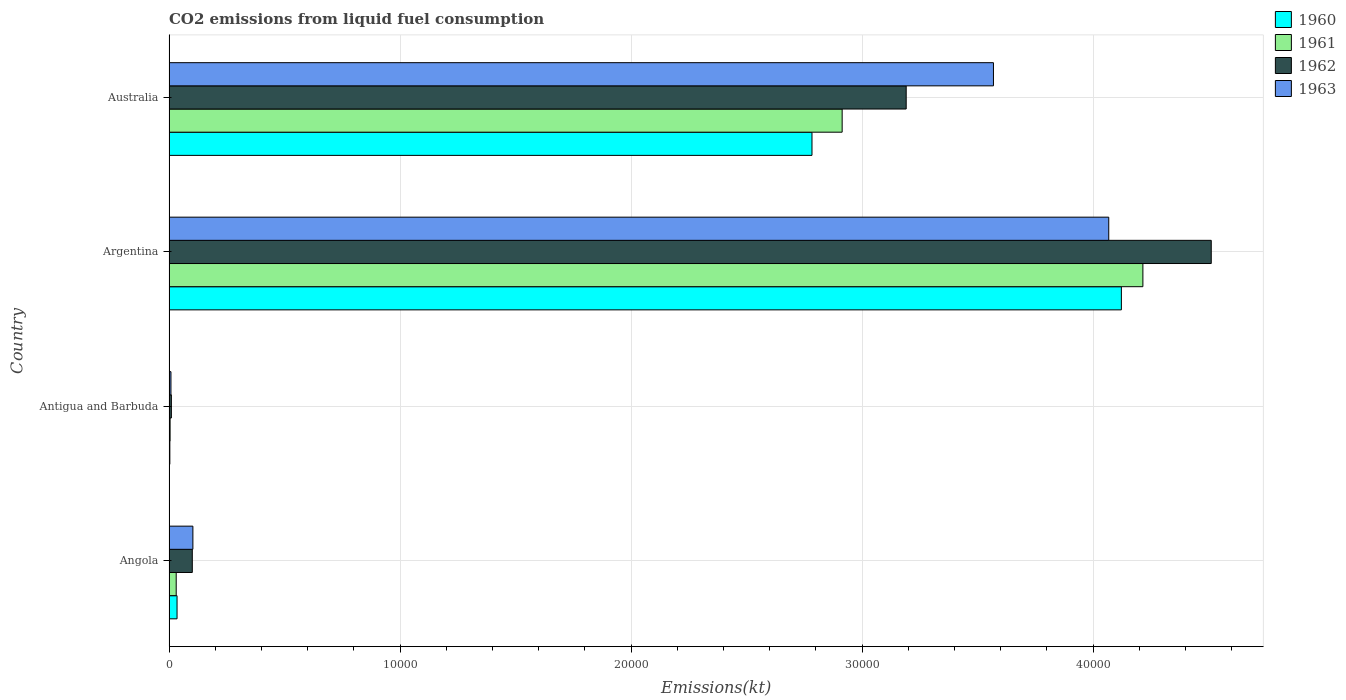Are the number of bars on each tick of the Y-axis equal?
Give a very brief answer. Yes. In how many cases, is the number of bars for a given country not equal to the number of legend labels?
Your response must be concise. 0. What is the amount of CO2 emitted in 1961 in Angola?
Keep it short and to the point. 311.69. Across all countries, what is the maximum amount of CO2 emitted in 1962?
Ensure brevity in your answer.  4.51e+04. Across all countries, what is the minimum amount of CO2 emitted in 1962?
Keep it short and to the point. 102.68. In which country was the amount of CO2 emitted in 1961 minimum?
Offer a very short reply. Antigua and Barbuda. What is the total amount of CO2 emitted in 1961 in the graph?
Offer a terse response. 7.17e+04. What is the difference between the amount of CO2 emitted in 1963 in Angola and that in Argentina?
Ensure brevity in your answer.  -3.96e+04. What is the difference between the amount of CO2 emitted in 1960 in Argentina and the amount of CO2 emitted in 1961 in Antigua and Barbuda?
Ensure brevity in your answer.  4.12e+04. What is the average amount of CO2 emitted in 1960 per country?
Offer a very short reply. 1.74e+04. What is the difference between the amount of CO2 emitted in 1961 and amount of CO2 emitted in 1963 in Argentina?
Offer a very short reply. 1477.8. In how many countries, is the amount of CO2 emitted in 1960 greater than 24000 kt?
Provide a short and direct response. 2. What is the ratio of the amount of CO2 emitted in 1963 in Angola to that in Antigua and Barbuda?
Keep it short and to the point. 12.26. What is the difference between the highest and the second highest amount of CO2 emitted in 1960?
Ensure brevity in your answer.  1.34e+04. What is the difference between the highest and the lowest amount of CO2 emitted in 1961?
Offer a terse response. 4.21e+04. Is it the case that in every country, the sum of the amount of CO2 emitted in 1961 and amount of CO2 emitted in 1960 is greater than the sum of amount of CO2 emitted in 1963 and amount of CO2 emitted in 1962?
Offer a terse response. No. What does the 1st bar from the top in Argentina represents?
Your answer should be very brief. 1963. Is it the case that in every country, the sum of the amount of CO2 emitted in 1963 and amount of CO2 emitted in 1962 is greater than the amount of CO2 emitted in 1960?
Your answer should be compact. Yes. How many bars are there?
Keep it short and to the point. 16. Are all the bars in the graph horizontal?
Offer a terse response. Yes. What is the difference between two consecutive major ticks on the X-axis?
Provide a succinct answer. 10000. Are the values on the major ticks of X-axis written in scientific E-notation?
Give a very brief answer. No. Does the graph contain any zero values?
Give a very brief answer. No. Does the graph contain grids?
Your answer should be very brief. Yes. Where does the legend appear in the graph?
Offer a terse response. Top right. How many legend labels are there?
Your answer should be compact. 4. What is the title of the graph?
Your answer should be very brief. CO2 emissions from liquid fuel consumption. What is the label or title of the X-axis?
Your answer should be compact. Emissions(kt). What is the label or title of the Y-axis?
Your answer should be very brief. Country. What is the Emissions(kt) in 1960 in Angola?
Your answer should be compact. 348.37. What is the Emissions(kt) in 1961 in Angola?
Your answer should be compact. 311.69. What is the Emissions(kt) in 1962 in Angola?
Provide a succinct answer. 1008.42. What is the Emissions(kt) of 1963 in Angola?
Give a very brief answer. 1034.09. What is the Emissions(kt) of 1960 in Antigua and Barbuda?
Keep it short and to the point. 36.67. What is the Emissions(kt) of 1961 in Antigua and Barbuda?
Your answer should be very brief. 47.67. What is the Emissions(kt) of 1962 in Antigua and Barbuda?
Your answer should be very brief. 102.68. What is the Emissions(kt) in 1963 in Antigua and Barbuda?
Make the answer very short. 84.34. What is the Emissions(kt) in 1960 in Argentina?
Provide a short and direct response. 4.12e+04. What is the Emissions(kt) in 1961 in Argentina?
Provide a succinct answer. 4.22e+04. What is the Emissions(kt) in 1962 in Argentina?
Offer a very short reply. 4.51e+04. What is the Emissions(kt) of 1963 in Argentina?
Offer a very short reply. 4.07e+04. What is the Emissions(kt) in 1960 in Australia?
Offer a very short reply. 2.78e+04. What is the Emissions(kt) in 1961 in Australia?
Your answer should be very brief. 2.91e+04. What is the Emissions(kt) of 1962 in Australia?
Your answer should be very brief. 3.19e+04. What is the Emissions(kt) of 1963 in Australia?
Keep it short and to the point. 3.57e+04. Across all countries, what is the maximum Emissions(kt) of 1960?
Give a very brief answer. 4.12e+04. Across all countries, what is the maximum Emissions(kt) of 1961?
Your answer should be very brief. 4.22e+04. Across all countries, what is the maximum Emissions(kt) of 1962?
Offer a very short reply. 4.51e+04. Across all countries, what is the maximum Emissions(kt) of 1963?
Offer a terse response. 4.07e+04. Across all countries, what is the minimum Emissions(kt) in 1960?
Your answer should be compact. 36.67. Across all countries, what is the minimum Emissions(kt) in 1961?
Ensure brevity in your answer.  47.67. Across all countries, what is the minimum Emissions(kt) of 1962?
Offer a very short reply. 102.68. Across all countries, what is the minimum Emissions(kt) in 1963?
Ensure brevity in your answer.  84.34. What is the total Emissions(kt) of 1960 in the graph?
Make the answer very short. 6.94e+04. What is the total Emissions(kt) in 1961 in the graph?
Provide a succinct answer. 7.17e+04. What is the total Emissions(kt) in 1962 in the graph?
Your answer should be compact. 7.81e+04. What is the total Emissions(kt) in 1963 in the graph?
Your response must be concise. 7.75e+04. What is the difference between the Emissions(kt) of 1960 in Angola and that in Antigua and Barbuda?
Keep it short and to the point. 311.69. What is the difference between the Emissions(kt) in 1961 in Angola and that in Antigua and Barbuda?
Your response must be concise. 264.02. What is the difference between the Emissions(kt) in 1962 in Angola and that in Antigua and Barbuda?
Give a very brief answer. 905.75. What is the difference between the Emissions(kt) of 1963 in Angola and that in Antigua and Barbuda?
Offer a terse response. 949.75. What is the difference between the Emissions(kt) of 1960 in Angola and that in Argentina?
Offer a terse response. -4.09e+04. What is the difference between the Emissions(kt) in 1961 in Angola and that in Argentina?
Offer a terse response. -4.18e+04. What is the difference between the Emissions(kt) in 1962 in Angola and that in Argentina?
Give a very brief answer. -4.41e+04. What is the difference between the Emissions(kt) in 1963 in Angola and that in Argentina?
Offer a very short reply. -3.96e+04. What is the difference between the Emissions(kt) in 1960 in Angola and that in Australia?
Provide a short and direct response. -2.75e+04. What is the difference between the Emissions(kt) of 1961 in Angola and that in Australia?
Provide a short and direct response. -2.88e+04. What is the difference between the Emissions(kt) in 1962 in Angola and that in Australia?
Ensure brevity in your answer.  -3.09e+04. What is the difference between the Emissions(kt) of 1963 in Angola and that in Australia?
Your answer should be very brief. -3.47e+04. What is the difference between the Emissions(kt) in 1960 in Antigua and Barbuda and that in Argentina?
Give a very brief answer. -4.12e+04. What is the difference between the Emissions(kt) of 1961 in Antigua and Barbuda and that in Argentina?
Your answer should be compact. -4.21e+04. What is the difference between the Emissions(kt) of 1962 in Antigua and Barbuda and that in Argentina?
Offer a terse response. -4.50e+04. What is the difference between the Emissions(kt) of 1963 in Antigua and Barbuda and that in Argentina?
Make the answer very short. -4.06e+04. What is the difference between the Emissions(kt) of 1960 in Antigua and Barbuda and that in Australia?
Keep it short and to the point. -2.78e+04. What is the difference between the Emissions(kt) in 1961 in Antigua and Barbuda and that in Australia?
Keep it short and to the point. -2.91e+04. What is the difference between the Emissions(kt) of 1962 in Antigua and Barbuda and that in Australia?
Make the answer very short. -3.18e+04. What is the difference between the Emissions(kt) of 1963 in Antigua and Barbuda and that in Australia?
Make the answer very short. -3.56e+04. What is the difference between the Emissions(kt) of 1960 in Argentina and that in Australia?
Provide a succinct answer. 1.34e+04. What is the difference between the Emissions(kt) of 1961 in Argentina and that in Australia?
Provide a succinct answer. 1.30e+04. What is the difference between the Emissions(kt) in 1962 in Argentina and that in Australia?
Make the answer very short. 1.32e+04. What is the difference between the Emissions(kt) of 1963 in Argentina and that in Australia?
Ensure brevity in your answer.  4990.79. What is the difference between the Emissions(kt) of 1960 in Angola and the Emissions(kt) of 1961 in Antigua and Barbuda?
Ensure brevity in your answer.  300.69. What is the difference between the Emissions(kt) of 1960 in Angola and the Emissions(kt) of 1962 in Antigua and Barbuda?
Provide a short and direct response. 245.69. What is the difference between the Emissions(kt) of 1960 in Angola and the Emissions(kt) of 1963 in Antigua and Barbuda?
Your response must be concise. 264.02. What is the difference between the Emissions(kt) in 1961 in Angola and the Emissions(kt) in 1962 in Antigua and Barbuda?
Your answer should be very brief. 209.02. What is the difference between the Emissions(kt) of 1961 in Angola and the Emissions(kt) of 1963 in Antigua and Barbuda?
Offer a very short reply. 227.35. What is the difference between the Emissions(kt) in 1962 in Angola and the Emissions(kt) in 1963 in Antigua and Barbuda?
Offer a very short reply. 924.08. What is the difference between the Emissions(kt) of 1960 in Angola and the Emissions(kt) of 1961 in Argentina?
Provide a succinct answer. -4.18e+04. What is the difference between the Emissions(kt) of 1960 in Angola and the Emissions(kt) of 1962 in Argentina?
Your answer should be compact. -4.48e+04. What is the difference between the Emissions(kt) in 1960 in Angola and the Emissions(kt) in 1963 in Argentina?
Offer a very short reply. -4.03e+04. What is the difference between the Emissions(kt) of 1961 in Angola and the Emissions(kt) of 1962 in Argentina?
Make the answer very short. -4.48e+04. What is the difference between the Emissions(kt) in 1961 in Angola and the Emissions(kt) in 1963 in Argentina?
Your answer should be very brief. -4.04e+04. What is the difference between the Emissions(kt) in 1962 in Angola and the Emissions(kt) in 1963 in Argentina?
Your response must be concise. -3.97e+04. What is the difference between the Emissions(kt) of 1960 in Angola and the Emissions(kt) of 1961 in Australia?
Keep it short and to the point. -2.88e+04. What is the difference between the Emissions(kt) of 1960 in Angola and the Emissions(kt) of 1962 in Australia?
Your answer should be very brief. -3.16e+04. What is the difference between the Emissions(kt) in 1960 in Angola and the Emissions(kt) in 1963 in Australia?
Keep it short and to the point. -3.53e+04. What is the difference between the Emissions(kt) in 1961 in Angola and the Emissions(kt) in 1962 in Australia?
Ensure brevity in your answer.  -3.16e+04. What is the difference between the Emissions(kt) of 1961 in Angola and the Emissions(kt) of 1963 in Australia?
Offer a very short reply. -3.54e+04. What is the difference between the Emissions(kt) of 1962 in Angola and the Emissions(kt) of 1963 in Australia?
Make the answer very short. -3.47e+04. What is the difference between the Emissions(kt) of 1960 in Antigua and Barbuda and the Emissions(kt) of 1961 in Argentina?
Provide a succinct answer. -4.21e+04. What is the difference between the Emissions(kt) of 1960 in Antigua and Barbuda and the Emissions(kt) of 1962 in Argentina?
Ensure brevity in your answer.  -4.51e+04. What is the difference between the Emissions(kt) of 1960 in Antigua and Barbuda and the Emissions(kt) of 1963 in Argentina?
Keep it short and to the point. -4.06e+04. What is the difference between the Emissions(kt) of 1961 in Antigua and Barbuda and the Emissions(kt) of 1962 in Argentina?
Ensure brevity in your answer.  -4.51e+04. What is the difference between the Emissions(kt) in 1961 in Antigua and Barbuda and the Emissions(kt) in 1963 in Argentina?
Offer a very short reply. -4.06e+04. What is the difference between the Emissions(kt) of 1962 in Antigua and Barbuda and the Emissions(kt) of 1963 in Argentina?
Offer a very short reply. -4.06e+04. What is the difference between the Emissions(kt) in 1960 in Antigua and Barbuda and the Emissions(kt) in 1961 in Australia?
Give a very brief answer. -2.91e+04. What is the difference between the Emissions(kt) in 1960 in Antigua and Barbuda and the Emissions(kt) in 1962 in Australia?
Ensure brevity in your answer.  -3.19e+04. What is the difference between the Emissions(kt) in 1960 in Antigua and Barbuda and the Emissions(kt) in 1963 in Australia?
Your answer should be compact. -3.57e+04. What is the difference between the Emissions(kt) in 1961 in Antigua and Barbuda and the Emissions(kt) in 1962 in Australia?
Your answer should be compact. -3.19e+04. What is the difference between the Emissions(kt) of 1961 in Antigua and Barbuda and the Emissions(kt) of 1963 in Australia?
Offer a very short reply. -3.56e+04. What is the difference between the Emissions(kt) in 1962 in Antigua and Barbuda and the Emissions(kt) in 1963 in Australia?
Keep it short and to the point. -3.56e+04. What is the difference between the Emissions(kt) of 1960 in Argentina and the Emissions(kt) of 1961 in Australia?
Your response must be concise. 1.21e+04. What is the difference between the Emissions(kt) of 1960 in Argentina and the Emissions(kt) of 1962 in Australia?
Give a very brief answer. 9314.18. What is the difference between the Emissions(kt) of 1960 in Argentina and the Emissions(kt) of 1963 in Australia?
Your response must be concise. 5537.17. What is the difference between the Emissions(kt) of 1961 in Argentina and the Emissions(kt) of 1962 in Australia?
Your answer should be very brief. 1.02e+04. What is the difference between the Emissions(kt) of 1961 in Argentina and the Emissions(kt) of 1963 in Australia?
Your answer should be very brief. 6468.59. What is the difference between the Emissions(kt) in 1962 in Argentina and the Emissions(kt) in 1963 in Australia?
Your response must be concise. 9427.86. What is the average Emissions(kt) in 1960 per country?
Offer a terse response. 1.74e+04. What is the average Emissions(kt) in 1961 per country?
Provide a succinct answer. 1.79e+04. What is the average Emissions(kt) in 1962 per country?
Keep it short and to the point. 1.95e+04. What is the average Emissions(kt) in 1963 per country?
Provide a succinct answer. 1.94e+04. What is the difference between the Emissions(kt) of 1960 and Emissions(kt) of 1961 in Angola?
Your answer should be very brief. 36.67. What is the difference between the Emissions(kt) in 1960 and Emissions(kt) in 1962 in Angola?
Keep it short and to the point. -660.06. What is the difference between the Emissions(kt) of 1960 and Emissions(kt) of 1963 in Angola?
Make the answer very short. -685.73. What is the difference between the Emissions(kt) of 1961 and Emissions(kt) of 1962 in Angola?
Provide a short and direct response. -696.73. What is the difference between the Emissions(kt) of 1961 and Emissions(kt) of 1963 in Angola?
Give a very brief answer. -722.4. What is the difference between the Emissions(kt) of 1962 and Emissions(kt) of 1963 in Angola?
Offer a terse response. -25.67. What is the difference between the Emissions(kt) in 1960 and Emissions(kt) in 1961 in Antigua and Barbuda?
Your response must be concise. -11. What is the difference between the Emissions(kt) of 1960 and Emissions(kt) of 1962 in Antigua and Barbuda?
Give a very brief answer. -66.01. What is the difference between the Emissions(kt) of 1960 and Emissions(kt) of 1963 in Antigua and Barbuda?
Keep it short and to the point. -47.67. What is the difference between the Emissions(kt) of 1961 and Emissions(kt) of 1962 in Antigua and Barbuda?
Your response must be concise. -55.01. What is the difference between the Emissions(kt) in 1961 and Emissions(kt) in 1963 in Antigua and Barbuda?
Provide a short and direct response. -36.67. What is the difference between the Emissions(kt) in 1962 and Emissions(kt) in 1963 in Antigua and Barbuda?
Offer a terse response. 18.34. What is the difference between the Emissions(kt) in 1960 and Emissions(kt) in 1961 in Argentina?
Make the answer very short. -931.42. What is the difference between the Emissions(kt) in 1960 and Emissions(kt) in 1962 in Argentina?
Provide a succinct answer. -3890.69. What is the difference between the Emissions(kt) of 1960 and Emissions(kt) of 1963 in Argentina?
Make the answer very short. 546.38. What is the difference between the Emissions(kt) in 1961 and Emissions(kt) in 1962 in Argentina?
Offer a terse response. -2959.27. What is the difference between the Emissions(kt) of 1961 and Emissions(kt) of 1963 in Argentina?
Offer a very short reply. 1477.8. What is the difference between the Emissions(kt) of 1962 and Emissions(kt) of 1963 in Argentina?
Give a very brief answer. 4437.07. What is the difference between the Emissions(kt) in 1960 and Emissions(kt) in 1961 in Australia?
Offer a very short reply. -1305.45. What is the difference between the Emissions(kt) of 1960 and Emissions(kt) of 1962 in Australia?
Your answer should be very brief. -4077.7. What is the difference between the Emissions(kt) in 1960 and Emissions(kt) in 1963 in Australia?
Offer a terse response. -7854.71. What is the difference between the Emissions(kt) of 1961 and Emissions(kt) of 1962 in Australia?
Keep it short and to the point. -2772.25. What is the difference between the Emissions(kt) of 1961 and Emissions(kt) of 1963 in Australia?
Keep it short and to the point. -6549.26. What is the difference between the Emissions(kt) of 1962 and Emissions(kt) of 1963 in Australia?
Give a very brief answer. -3777.01. What is the ratio of the Emissions(kt) in 1960 in Angola to that in Antigua and Barbuda?
Your answer should be very brief. 9.5. What is the ratio of the Emissions(kt) of 1961 in Angola to that in Antigua and Barbuda?
Provide a short and direct response. 6.54. What is the ratio of the Emissions(kt) in 1962 in Angola to that in Antigua and Barbuda?
Your answer should be very brief. 9.82. What is the ratio of the Emissions(kt) in 1963 in Angola to that in Antigua and Barbuda?
Offer a very short reply. 12.26. What is the ratio of the Emissions(kt) in 1960 in Angola to that in Argentina?
Ensure brevity in your answer.  0.01. What is the ratio of the Emissions(kt) of 1961 in Angola to that in Argentina?
Offer a terse response. 0.01. What is the ratio of the Emissions(kt) of 1962 in Angola to that in Argentina?
Your response must be concise. 0.02. What is the ratio of the Emissions(kt) in 1963 in Angola to that in Argentina?
Your response must be concise. 0.03. What is the ratio of the Emissions(kt) of 1960 in Angola to that in Australia?
Give a very brief answer. 0.01. What is the ratio of the Emissions(kt) in 1961 in Angola to that in Australia?
Provide a succinct answer. 0.01. What is the ratio of the Emissions(kt) in 1962 in Angola to that in Australia?
Your answer should be very brief. 0.03. What is the ratio of the Emissions(kt) in 1963 in Angola to that in Australia?
Keep it short and to the point. 0.03. What is the ratio of the Emissions(kt) in 1960 in Antigua and Barbuda to that in Argentina?
Ensure brevity in your answer.  0. What is the ratio of the Emissions(kt) of 1961 in Antigua and Barbuda to that in Argentina?
Offer a very short reply. 0. What is the ratio of the Emissions(kt) of 1962 in Antigua and Barbuda to that in Argentina?
Your response must be concise. 0. What is the ratio of the Emissions(kt) in 1963 in Antigua and Barbuda to that in Argentina?
Your answer should be very brief. 0. What is the ratio of the Emissions(kt) of 1960 in Antigua and Barbuda to that in Australia?
Your answer should be compact. 0. What is the ratio of the Emissions(kt) in 1961 in Antigua and Barbuda to that in Australia?
Give a very brief answer. 0. What is the ratio of the Emissions(kt) of 1962 in Antigua and Barbuda to that in Australia?
Provide a succinct answer. 0. What is the ratio of the Emissions(kt) in 1963 in Antigua and Barbuda to that in Australia?
Offer a terse response. 0. What is the ratio of the Emissions(kt) of 1960 in Argentina to that in Australia?
Keep it short and to the point. 1.48. What is the ratio of the Emissions(kt) of 1961 in Argentina to that in Australia?
Your answer should be compact. 1.45. What is the ratio of the Emissions(kt) of 1962 in Argentina to that in Australia?
Keep it short and to the point. 1.41. What is the ratio of the Emissions(kt) in 1963 in Argentina to that in Australia?
Make the answer very short. 1.14. What is the difference between the highest and the second highest Emissions(kt) of 1960?
Give a very brief answer. 1.34e+04. What is the difference between the highest and the second highest Emissions(kt) in 1961?
Your response must be concise. 1.30e+04. What is the difference between the highest and the second highest Emissions(kt) of 1962?
Your answer should be compact. 1.32e+04. What is the difference between the highest and the second highest Emissions(kt) of 1963?
Offer a terse response. 4990.79. What is the difference between the highest and the lowest Emissions(kt) of 1960?
Provide a short and direct response. 4.12e+04. What is the difference between the highest and the lowest Emissions(kt) of 1961?
Your answer should be compact. 4.21e+04. What is the difference between the highest and the lowest Emissions(kt) in 1962?
Ensure brevity in your answer.  4.50e+04. What is the difference between the highest and the lowest Emissions(kt) in 1963?
Your answer should be compact. 4.06e+04. 